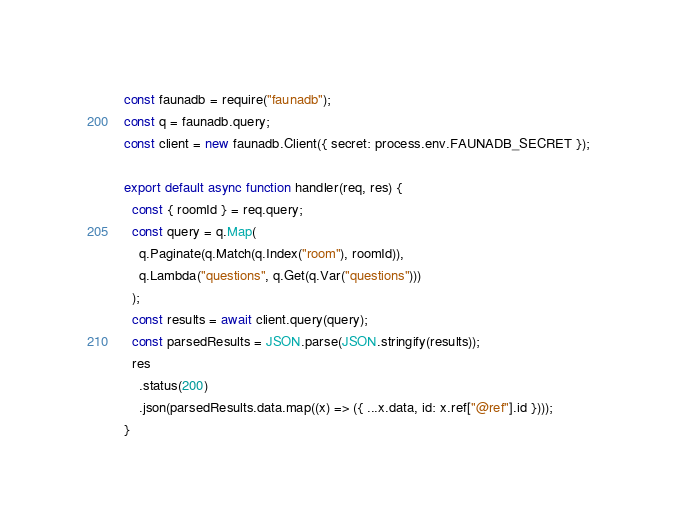<code> <loc_0><loc_0><loc_500><loc_500><_JavaScript_>const faunadb = require("faunadb");
const q = faunadb.query;
const client = new faunadb.Client({ secret: process.env.FAUNADB_SECRET });

export default async function handler(req, res) {
  const { roomId } = req.query;
  const query = q.Map(
    q.Paginate(q.Match(q.Index("room"), roomId)),
    q.Lambda("questions", q.Get(q.Var("questions")))
  );
  const results = await client.query(query);
  const parsedResults = JSON.parse(JSON.stringify(results));
  res
    .status(200)
    .json(parsedResults.data.map((x) => ({ ...x.data, id: x.ref["@ref"].id })));
}
</code> 